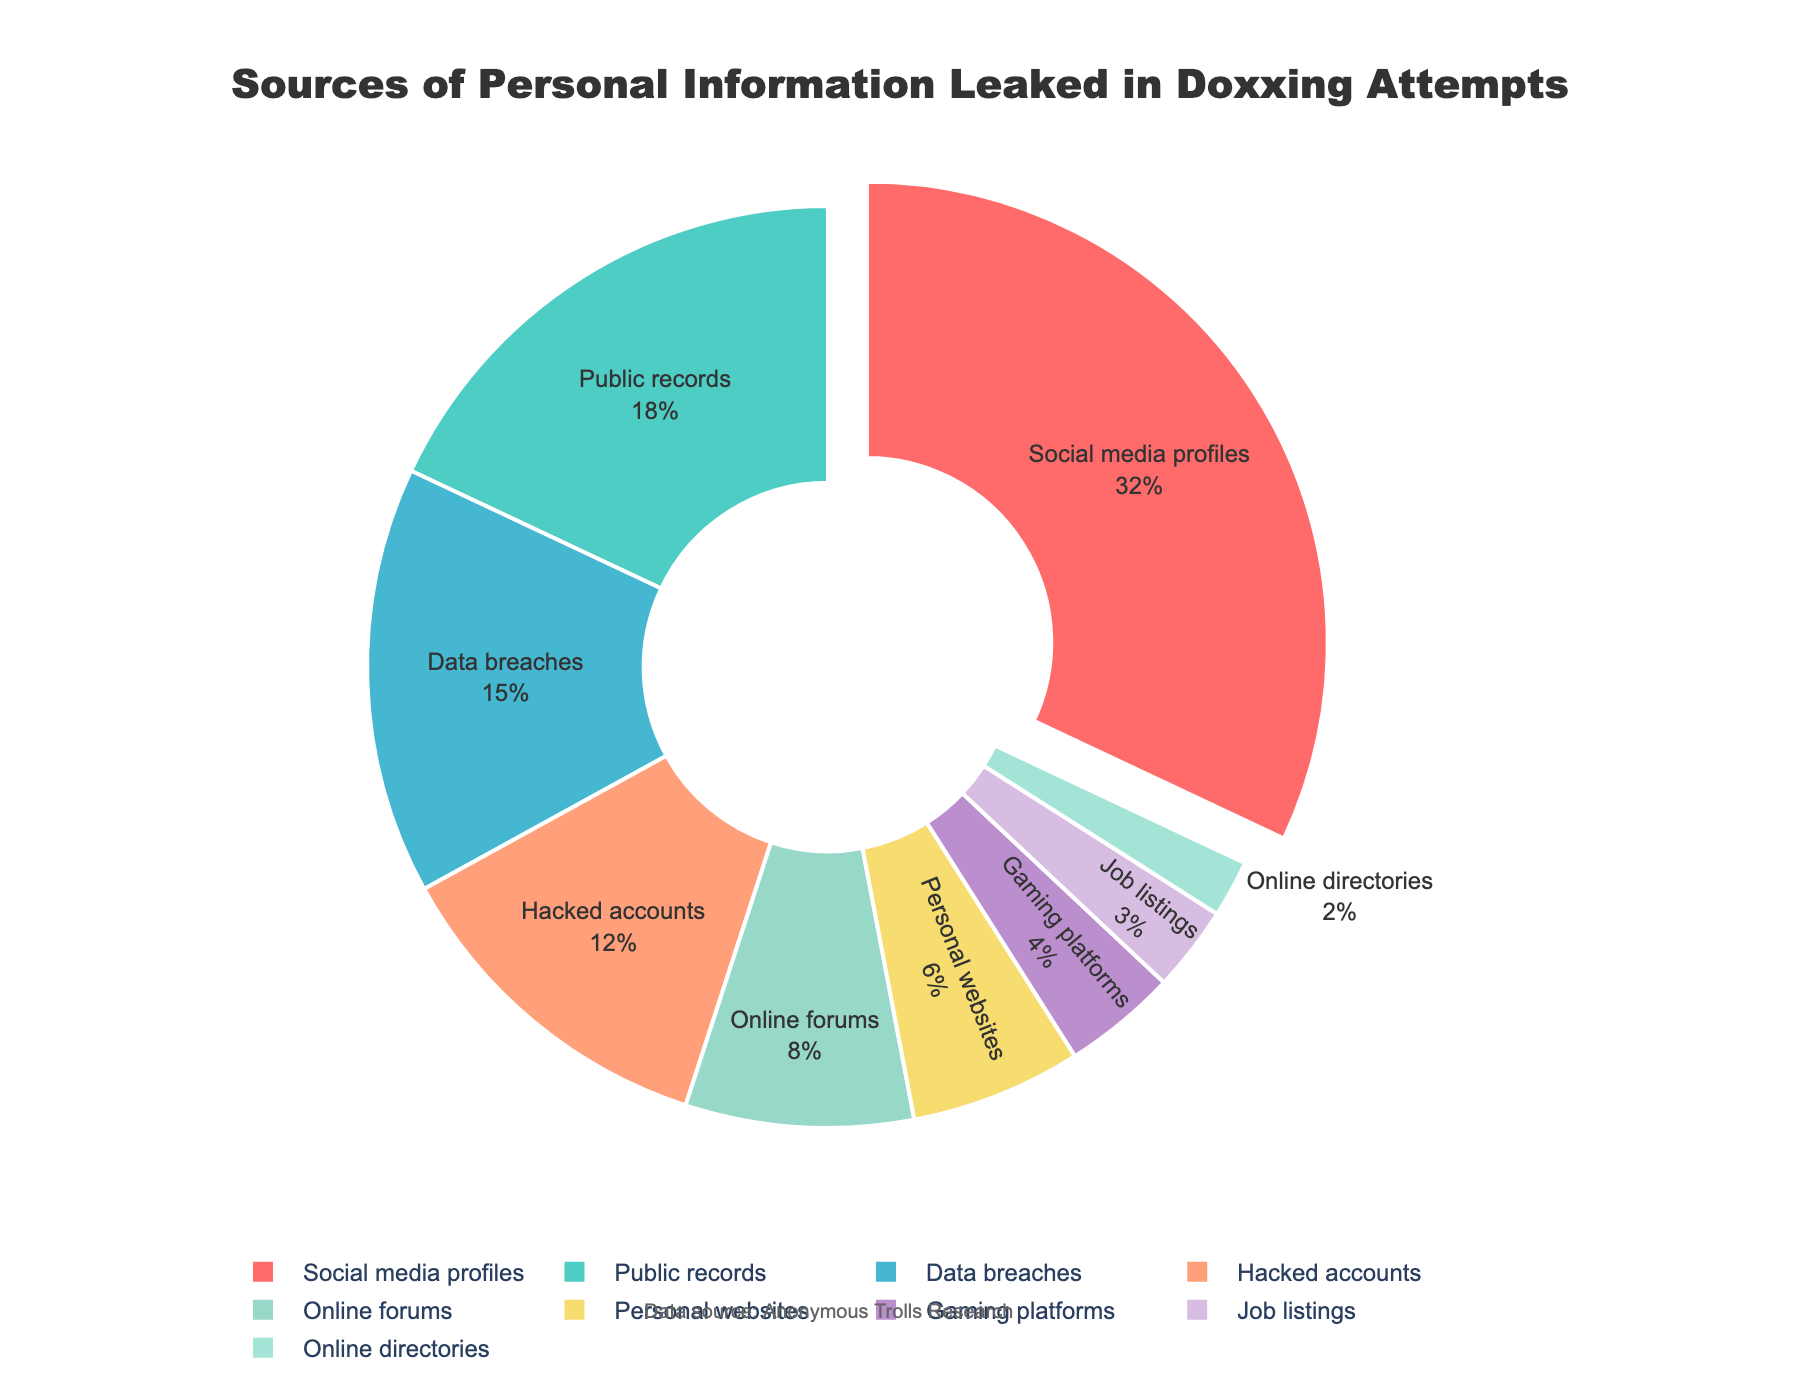Which source has the highest percentage of leaked personal information? The chart indicates the size of each segment by percentage. The largest segment belongs to "Social media profiles" with 32%.
Answer: Social media profiles Which two sources combined account for the highest percentage? We need to combine the percentages and find the largest sum. "Social media profiles" (32%) and "Public records" (18%) sum up to 50%, which is higher than any other pair.
Answer: Social media profiles and Public records Is the percentage of information leaked from online forums greater than that from personal websites? We compare the two percentages: online forums have 8% and personal websites have 6%. Since 8% is greater than 6%, the answer is yes.
Answer: Yes How much higher is the percentage of leaks from hacked accounts compared to gaming platforms? The percentage for hacked accounts is 12% and for gaming platforms is 4%. Subtract the smaller from the larger: 12% - 4% = 8%.
Answer: 8% Which segments are smaller than 5%? We look for segments with percentages less than 5%. "Gaming platforms" (4%), "Job listings" (3%), and "Online directories" (2%) are all under 5%.
Answer: Gaming platforms, Job listings, Online directories Are hacked accounts and data breaches contributing equally to personal information leaks? The chart shows percentages for both; hacked accounts have 12% and data breaches have 15%. Since 12% is not equal to 15%, the answer is no.
Answer: No What is the total percentage of information leaked from personal websites, job listings, and online directories combined? Sum the percentages of personal websites (6%), job listings (3%), and online directories (2%): 6% + 3% + 2% = 11%.
Answer: 11% Which category is represented by the red segment? To identify the color, we look at the first segment in the legend associated with the red color, which corresponds to "Social media profiles" at 32%.
Answer: Social media profiles 